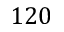Convert formula to latex. <formula><loc_0><loc_0><loc_500><loc_500>1 2 0</formula> 